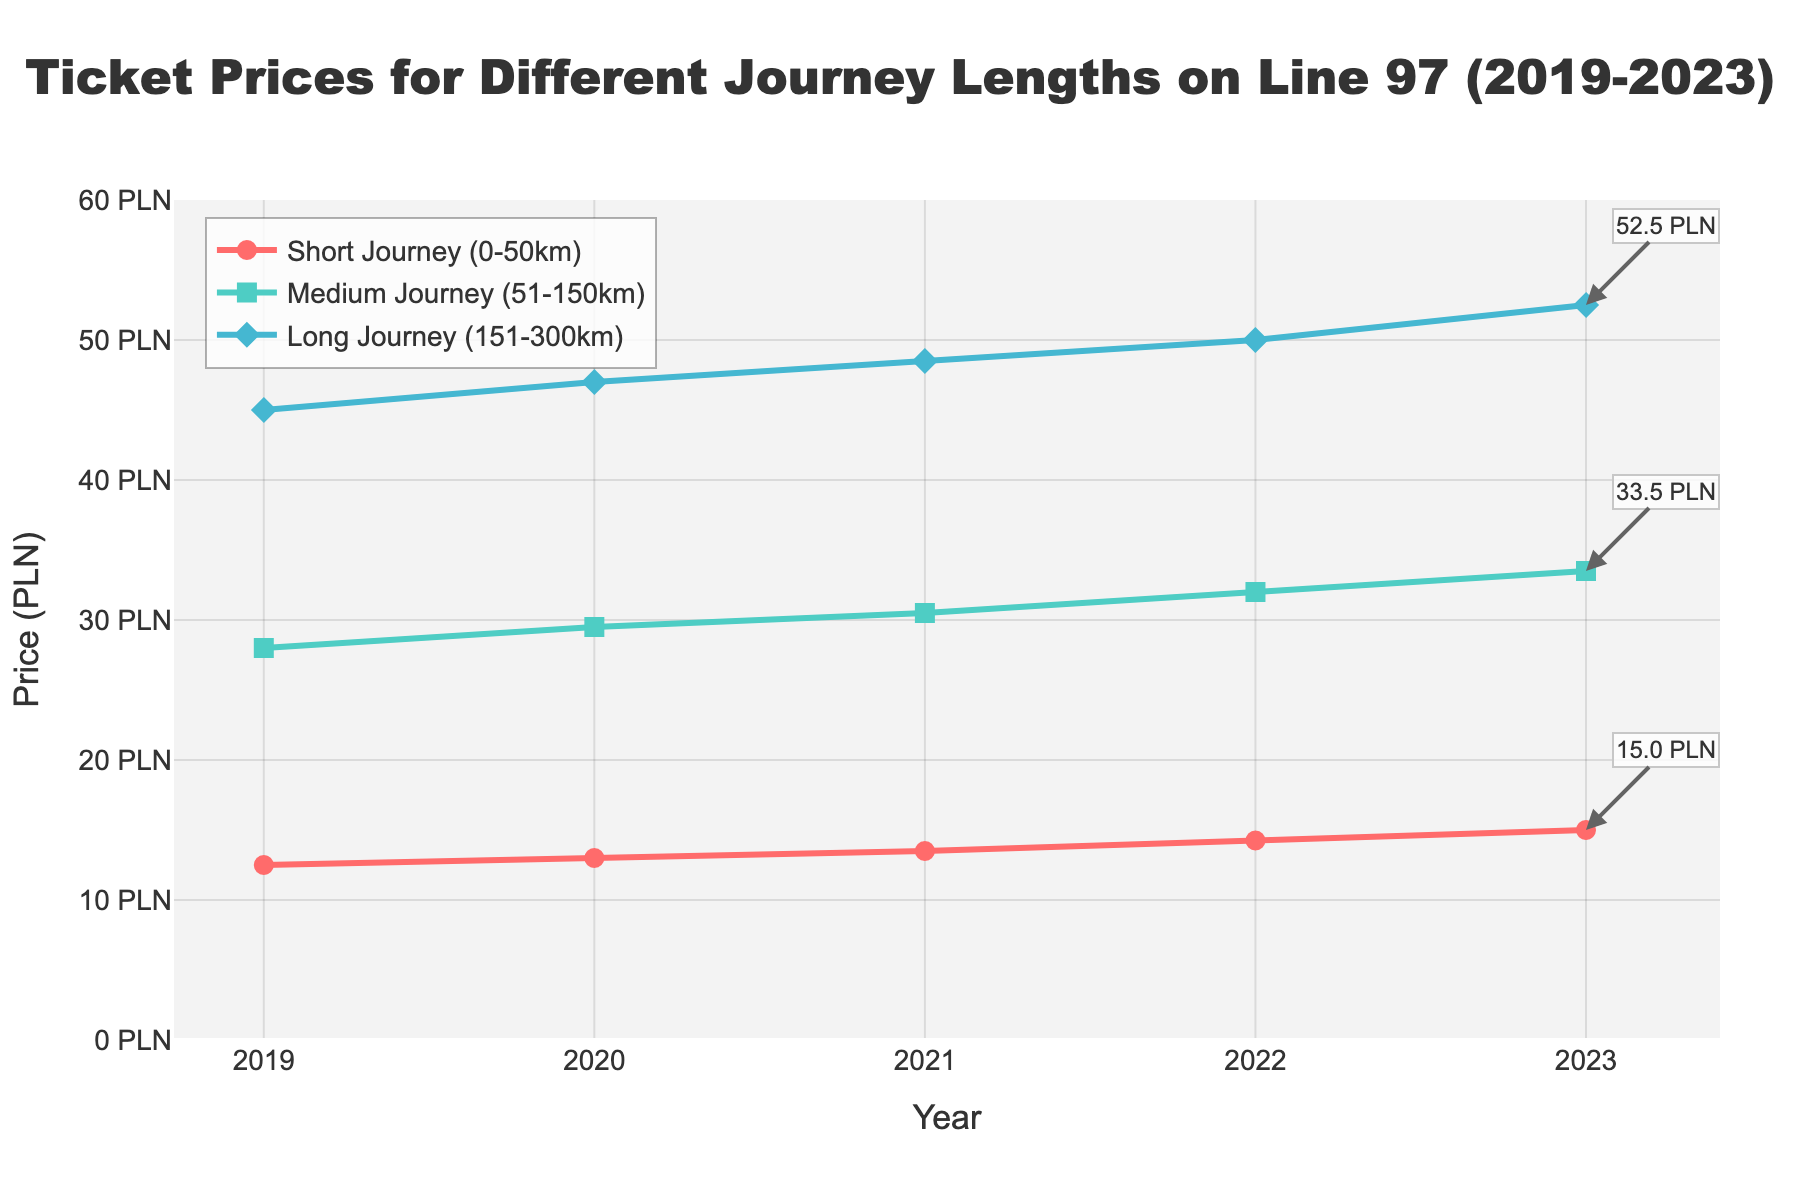What's the price of a short journey (0-50km) ticket in 2023? Look at the line for Short Journey (0-50km) and find the data point for the year 2023. The price is indicated at the endpoint.
Answer: 15.00 PLN How much did the price of a medium journey (51-150km) increase from 2019 to 2023? Find the medium journey prices for both 2019 and 2023 and calculate the difference: 33.50 PLN - 28.00 PLN.
Answer: 5.50 PLN What is the average price of a long journey (151-300km) ticket over the 5 years? Sum the prices for long journeys from 2019 to 2023 and divide by 5: (45.00 + 47.00 + 48.50 + 50.00 + 52.50) / 5.
Answer: 48.60 PLN Which journey type saw the greatest increase in price over the 5-year period? Calculate the price differences for each journey type from 2019 to 2023 and compare: Short (15.00-12.50=2.50), Medium (33.50-28.00=5.50), Long (52.50-45.00=7.50).
Answer: Long Journey (7.50 PLN) What is the total price a passenger would pay if they bought one ticket of each type in 2021? Add the prices for short, medium, and long journey tickets in 2021: 13.50 PLN + 30.50 PLN + 48.50 PLN.
Answer: 92.50 PLN How does the price change for long journeys from 2020 to 2021 compare to the price change for short journeys in the same period? Calculate the differences: Long Journey (48.50-47.00) and Short Journey (13.50-13.00). Compare the results.
Answer: Long Journey (1.50 PLN) is higher than Short Journey (0.50 PLN) How many PLN does the short journey ticket increase each year on average from 2019 to 2023? Calculate the total increase over the period and divide by the number of years: (15.00 - 12.50) / 4.
Answer: 0.625 PLN per year Among the three journey types, which one had the least price increase from 2021 to 2022? Calculate the price differences for each journey type: Short Journey (14.25-13.50), Medium Journey (32.00-30.50), Long Journey (50.00-48.50). Compare the results.
Answer: Short Journey (0.75 PLN) What's the color of the line representing medium journey (51-150km) prices? Identify the color corresponding to the Medium Journey line in the chart.
Answer: Green 